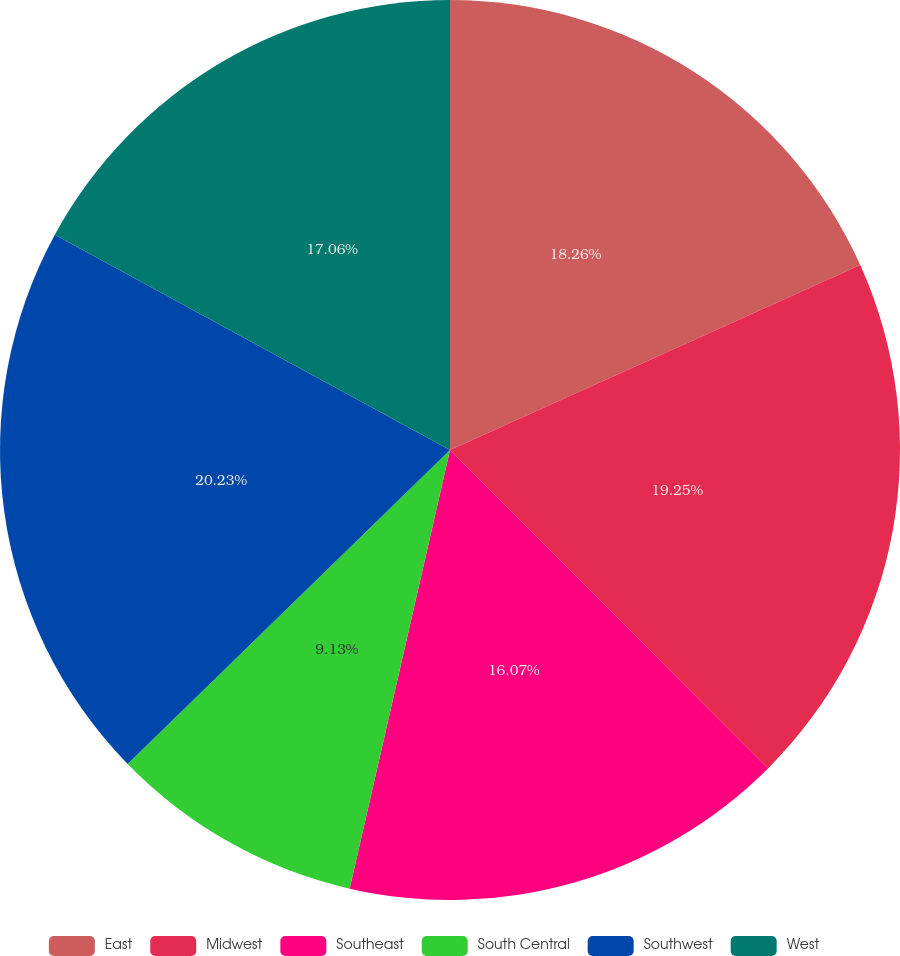<chart> <loc_0><loc_0><loc_500><loc_500><pie_chart><fcel>East<fcel>Midwest<fcel>Southeast<fcel>South Central<fcel>Southwest<fcel>West<nl><fcel>18.26%<fcel>19.25%<fcel>16.07%<fcel>9.13%<fcel>20.23%<fcel>17.06%<nl></chart> 